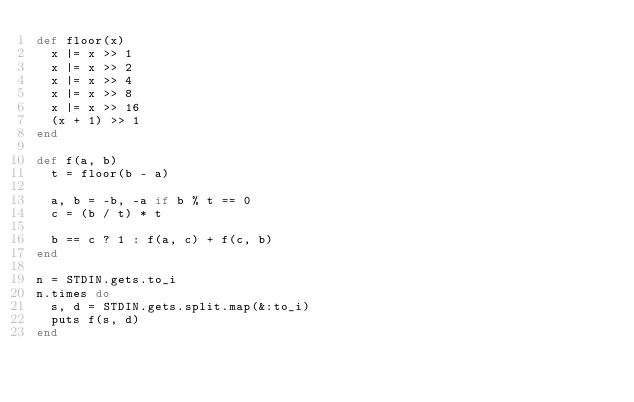Convert code to text. <code><loc_0><loc_0><loc_500><loc_500><_Ruby_>def floor(x)
  x |= x >> 1
  x |= x >> 2
  x |= x >> 4
  x |= x >> 8
  x |= x >> 16
  (x + 1) >> 1
end

def f(a, b)
  t = floor(b - a)

  a, b = -b, -a if b % t == 0
  c = (b / t) * t
    
  b == c ? 1 : f(a, c) + f(c, b)
end

n = STDIN.gets.to_i
n.times do
  s, d = STDIN.gets.split.map(&:to_i)
  puts f(s, d)
end</code> 